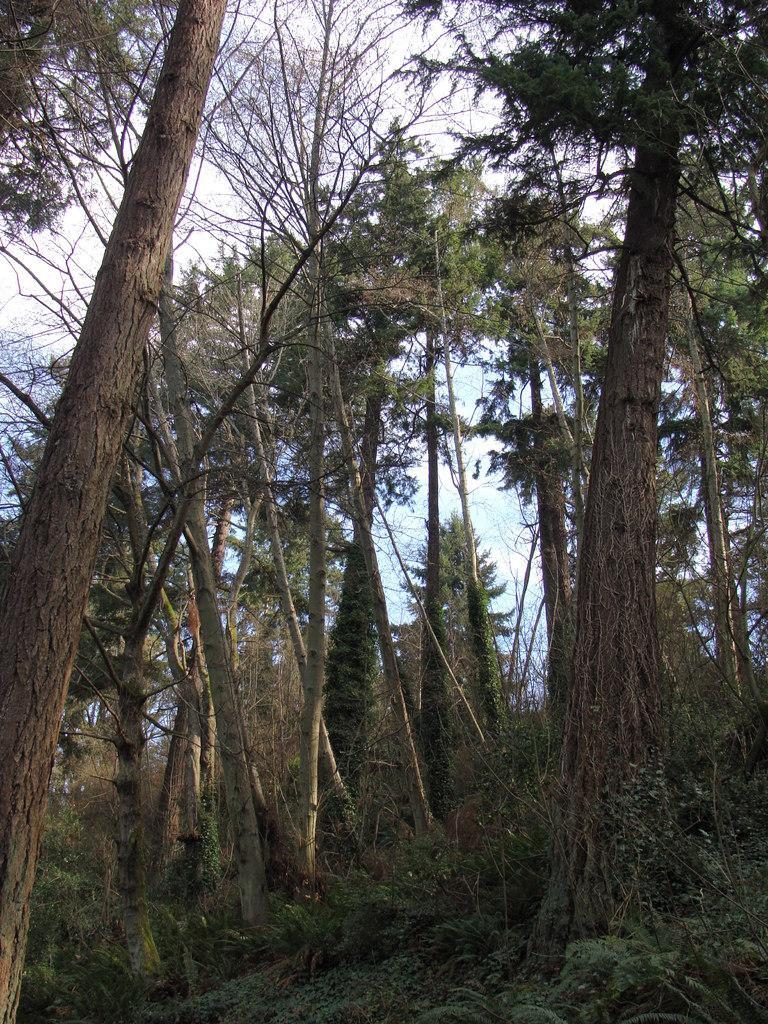Please provide a concise description of this image. In this picture we can see trees, plants on the ground and we can see sky in the background. 